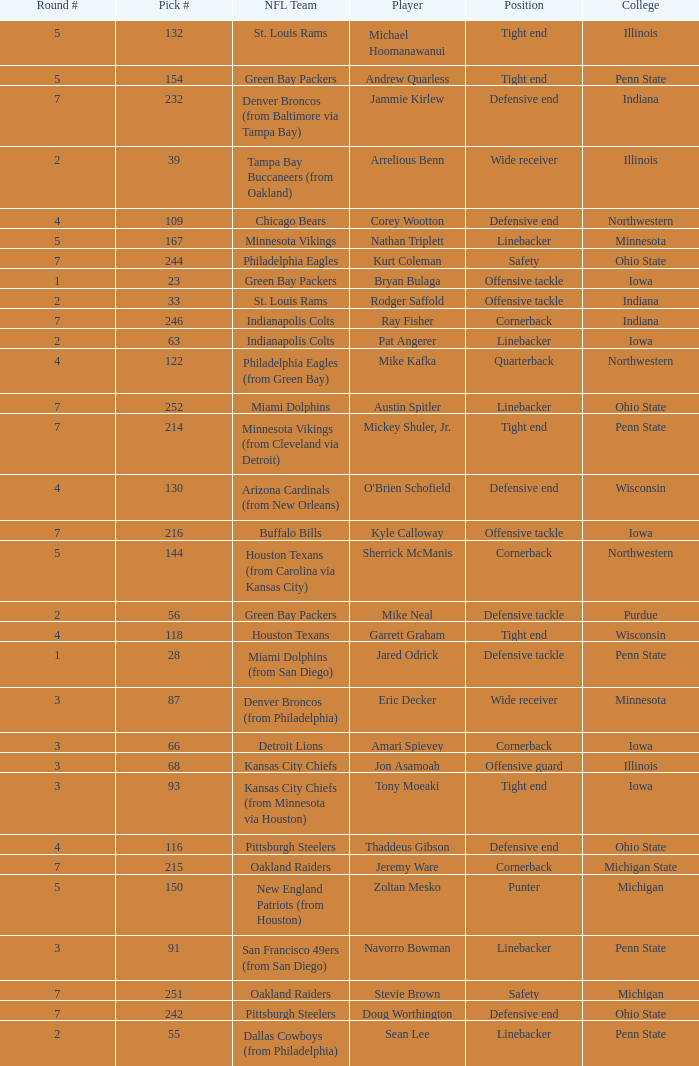What NFL team was the player with pick number 28 drafted to? Miami Dolphins (from San Diego). 